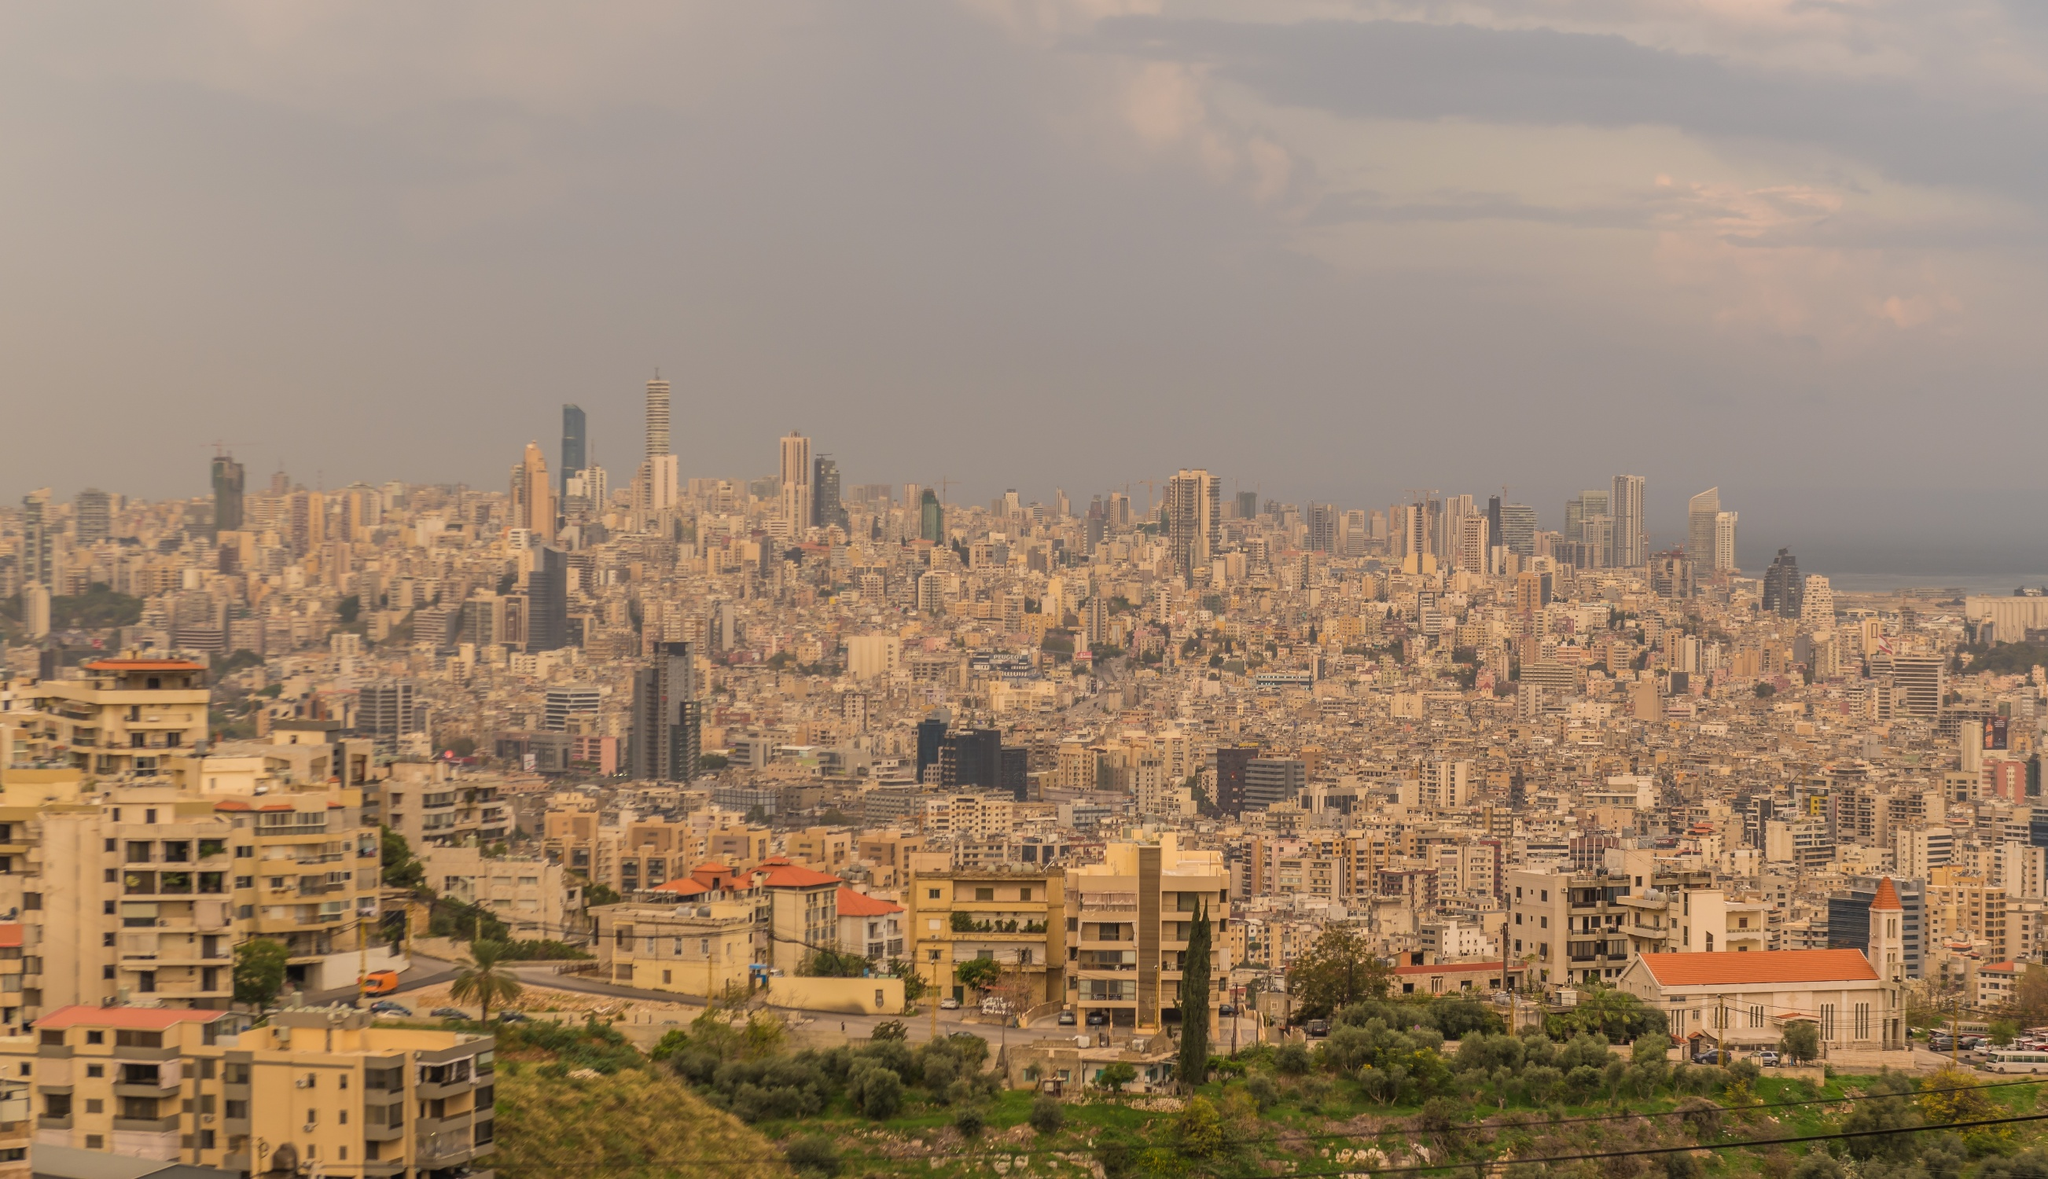What do you think is going on in this snapshot? The image presents a dramatic and expansive view of Beirut. This capital city is a tapestry of history, showing off modern skyscrapers, traditional buildings, and construction in progress, evidencing a city in constant evolution. The notable presence of green areas amid the dense urban environment suggests an attempt to maintain some balance with nature. The picture’s orange tint beautifully captures the golden hour, enhancing the city's contours and highlighting its vibrant and dynamic nature. Off in the horizon, the calm Mediterranean Sea contrasts with the city’s hustle and bustle, emphasizing Beirut's unique geographic setting. 